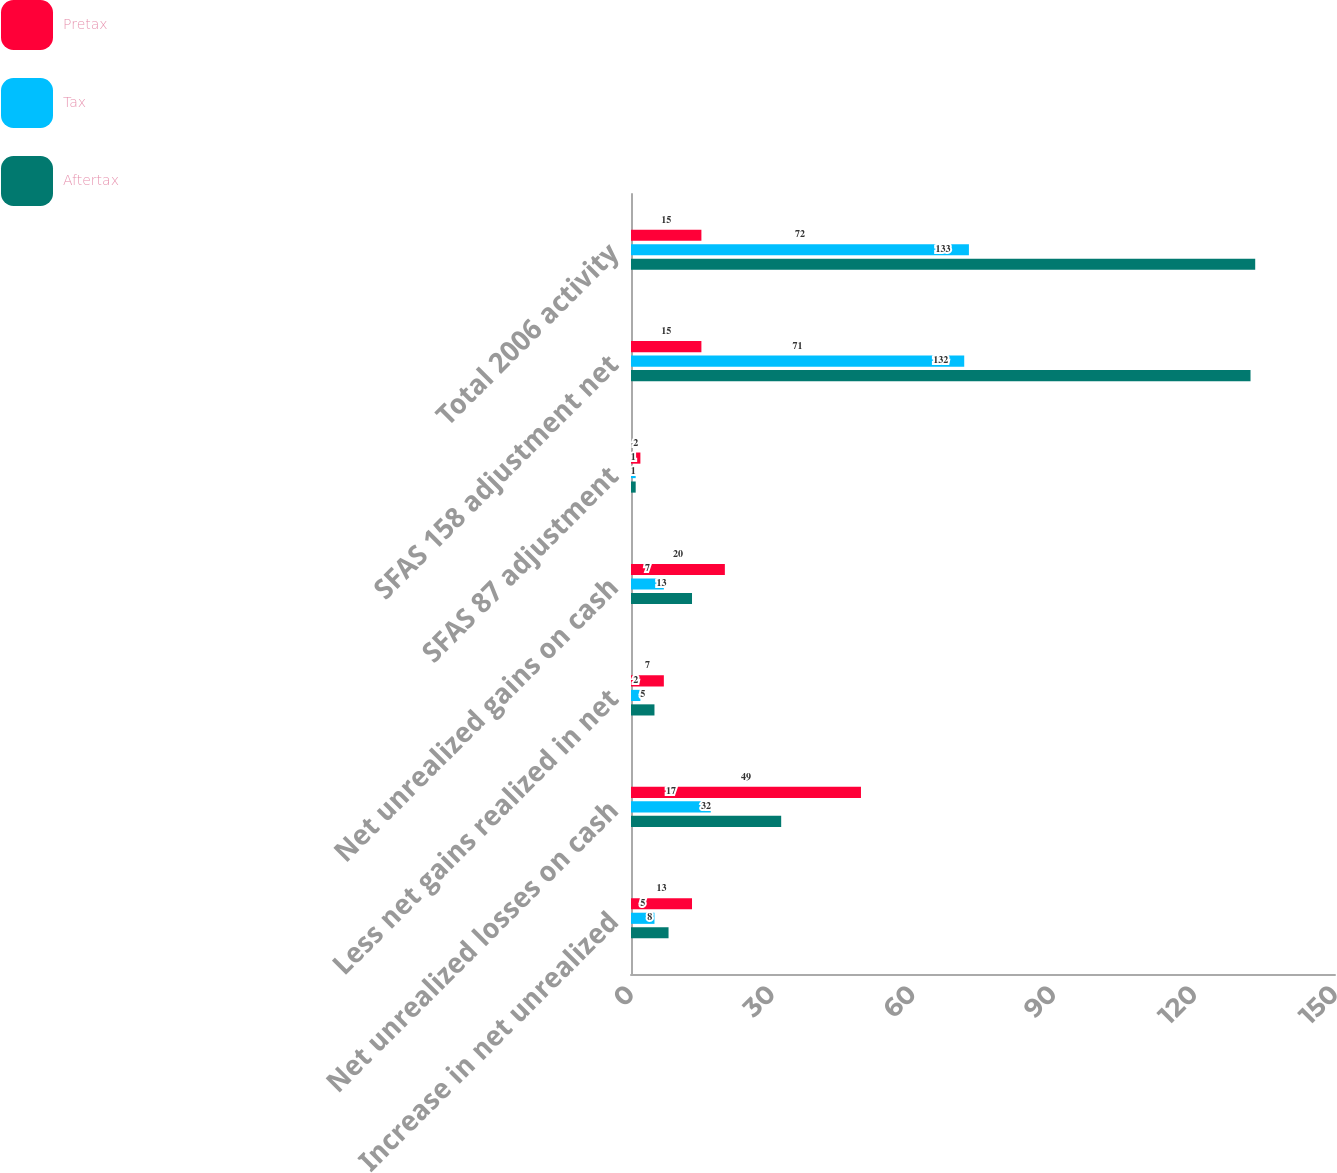Convert chart. <chart><loc_0><loc_0><loc_500><loc_500><stacked_bar_chart><ecel><fcel>Increase in net unrealized<fcel>Net unrealized losses on cash<fcel>Less net gains realized in net<fcel>Net unrealized gains on cash<fcel>SFAS 87 adjustment<fcel>SFAS 158 adjustment net<fcel>Total 2006 activity<nl><fcel>Pretax<fcel>13<fcel>49<fcel>7<fcel>20<fcel>2<fcel>15<fcel>15<nl><fcel>Tax<fcel>5<fcel>17<fcel>2<fcel>7<fcel>1<fcel>71<fcel>72<nl><fcel>Aftertax<fcel>8<fcel>32<fcel>5<fcel>13<fcel>1<fcel>132<fcel>133<nl></chart> 